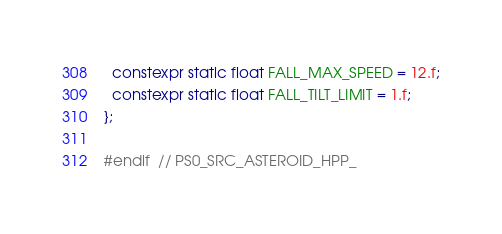<code> <loc_0><loc_0><loc_500><loc_500><_C++_>  constexpr static float FALL_MAX_SPEED = 12.f;
  constexpr static float FALL_TILT_LIMIT = 1.f;
};

#endif  // PS0_SRC_ASTEROID_HPP_
</code> 